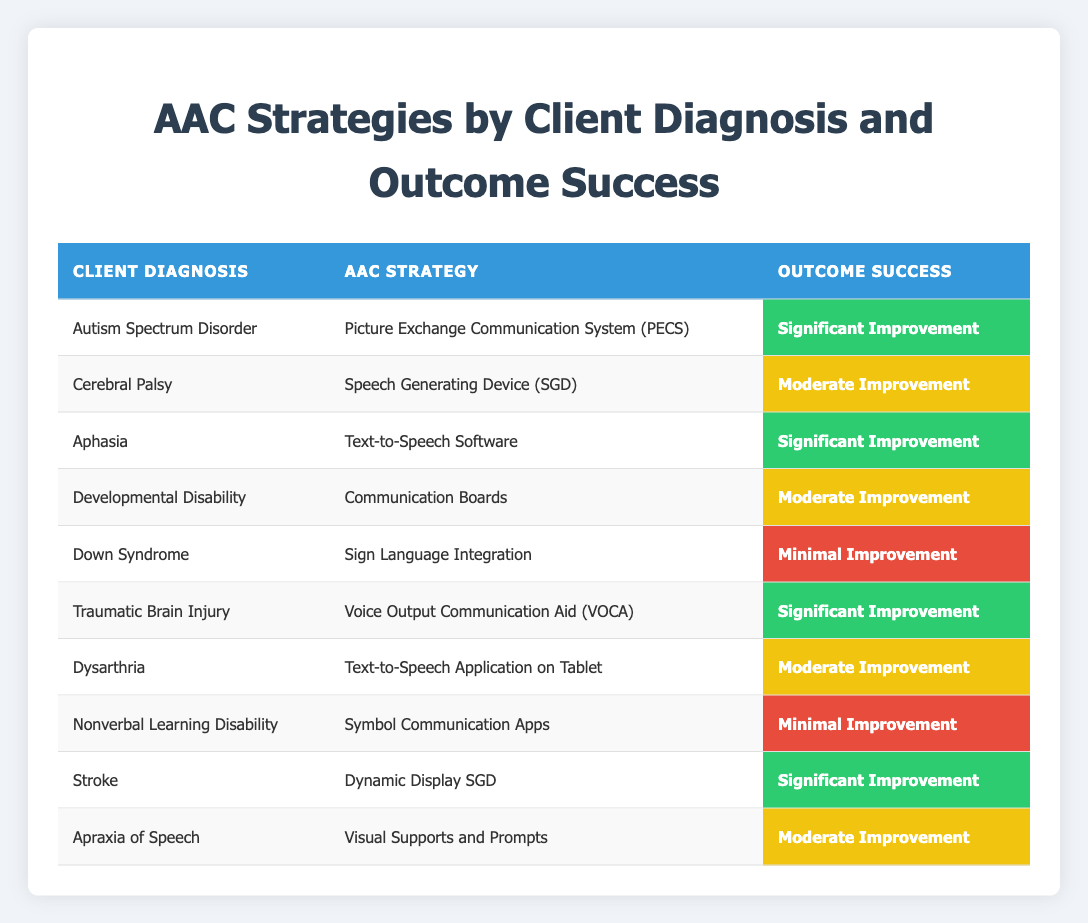What AAC strategy corresponds to the client diagnosis of Autism Spectrum Disorder? The table lists "Autism Spectrum Disorder" under the "Client Diagnosis" column, and the corresponding "AAC Strategy" in the same row is "Picture Exchange Communication System (PECS)."
Answer: Picture Exchange Communication System (PECS) How many diagnoses show significant improvement outcomes? By counting the rows in the "Outcome Success" column that are labeled "Significant Improvement," we find four: "Autism Spectrum Disorder," "Aphasia," "Traumatic Brain Injury," and "Stroke."
Answer: 4 Is the outcome success for "Dysarthria" classified as minimal improvement? Referring to the row with "Dysarthria" in the table, the "Outcome Success" column indicates "Moderate Improvement," which confirms that the statement is false.
Answer: No Which AAC strategy had the least successful outcome and what was that success level? The row for "Nonverbal Learning Disability" indicates "Symbol Communication Apps," with an "Outcome Success" of "Minimal Improvement," making it the least successful outcome in the table.
Answer: Symbol Communication Apps, Minimal Improvement What is the overall distribution of outcome success levels in the table (e.g. how many moderate, minimal, and significant improvements)? Counting the outcomes shows: 4 Significant Improvement, 4 Moderate Improvement, and 2 Minimal Improvement. These counts provide a distribution of the outcome success levels.
Answer: 4 Significant, 4 Moderate, 2 Minimal Which diagnosis corresponds to the strategy "Dynamic Display SGD"? The table shows that the diagnosis listed in the row with "Dynamic Display SGD" is "Stroke." Thus, the diagnosis corresponding to this strategy is "Stroke."
Answer: Stroke What is the total number of clients represented in the table? The table contains a total of 10 distinct rows, each representing a different client's diagnosis, thus indicating there are 10 clients in total.
Answer: 10 Identify the diagnosis associated with the "Voice Output Communication Aid (VOCA)" strategy and its success outcome. In the table, the strategy "Voice Output Communication Aid (VOCA)" corresponds to the diagnosis "Traumatic Brain Injury," which has an outcome of "Significant Improvement."
Answer: Traumatic Brain Injury, Significant Improvement Are there more diagnoses with moderate improvement than those with minimal improvement? Checking the counts, there are 4 diagnoses with "Moderate Improvement" compared to 2 with "Minimal Improvement," confirming that there are indeed more moderate than minimal improvements.
Answer: Yes 